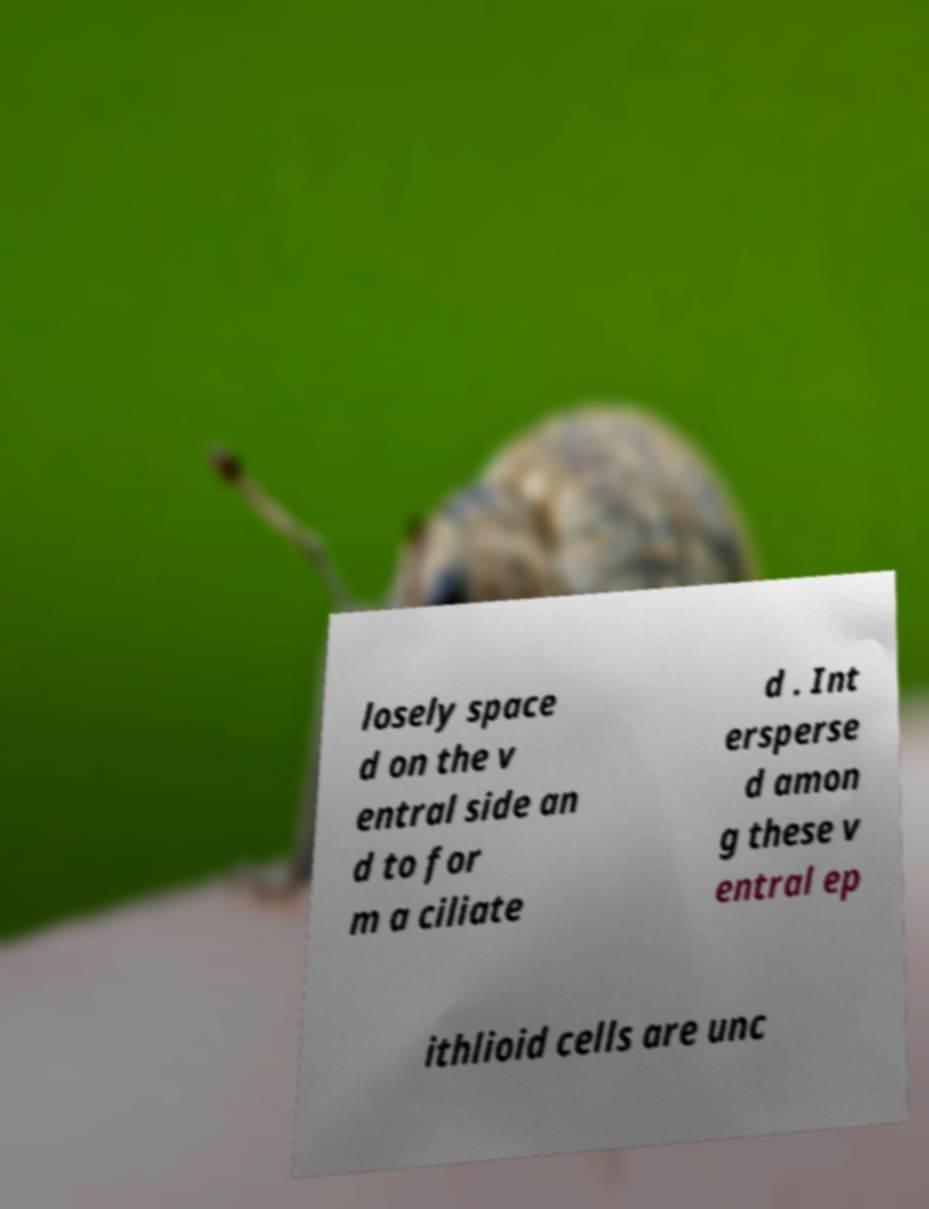Please identify and transcribe the text found in this image. losely space d on the v entral side an d to for m a ciliate d . Int ersperse d amon g these v entral ep ithlioid cells are unc 